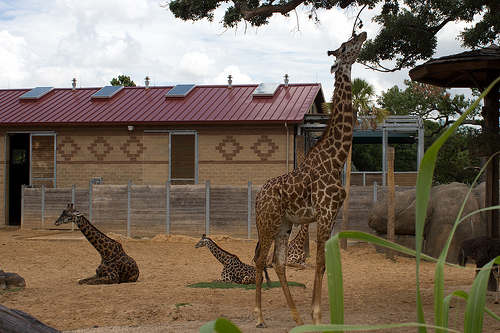Please provide a short description for this region: [0.62, 0.36, 0.89, 0.56]. The specified coordinates [0.62, 0.36, 0.89, 0.56] refer to a canopy covering part of the building. 